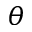Convert formula to latex. <formula><loc_0><loc_0><loc_500><loc_500>\theta</formula> 